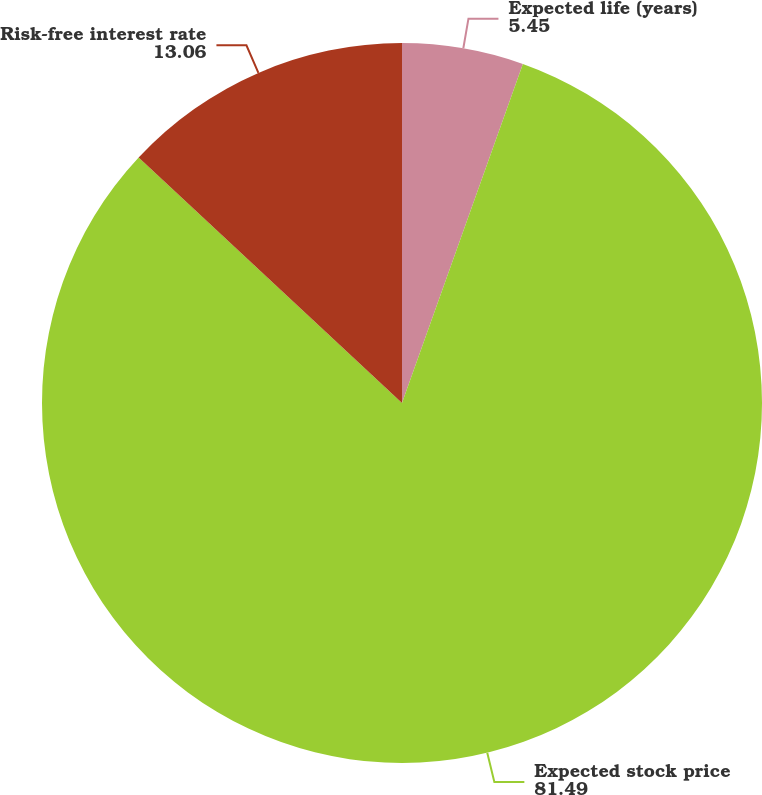<chart> <loc_0><loc_0><loc_500><loc_500><pie_chart><fcel>Expected life (years)<fcel>Expected stock price<fcel>Risk-free interest rate<nl><fcel>5.45%<fcel>81.49%<fcel>13.06%<nl></chart> 